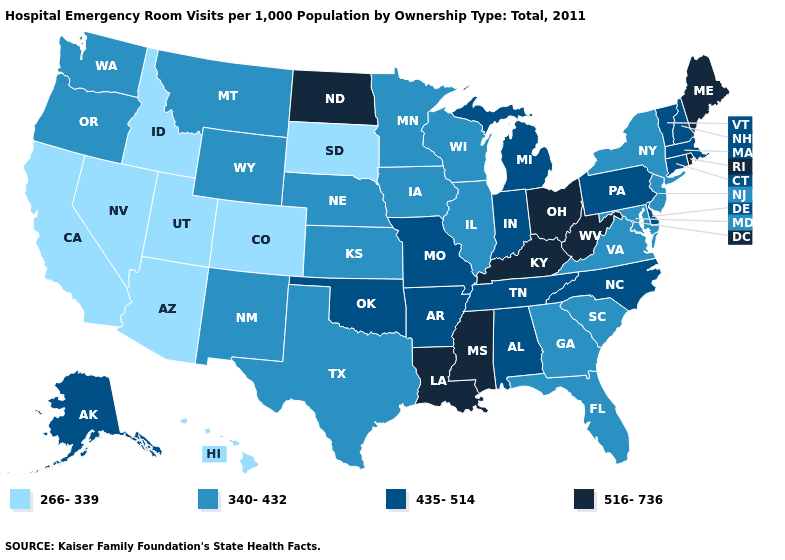What is the value of Utah?
Short answer required. 266-339. Name the states that have a value in the range 435-514?
Answer briefly. Alabama, Alaska, Arkansas, Connecticut, Delaware, Indiana, Massachusetts, Michigan, Missouri, New Hampshire, North Carolina, Oklahoma, Pennsylvania, Tennessee, Vermont. Which states have the highest value in the USA?
Write a very short answer. Kentucky, Louisiana, Maine, Mississippi, North Dakota, Ohio, Rhode Island, West Virginia. Among the states that border Nevada , does California have the highest value?
Be succinct. No. What is the lowest value in states that border Alabama?
Give a very brief answer. 340-432. Name the states that have a value in the range 266-339?
Give a very brief answer. Arizona, California, Colorado, Hawaii, Idaho, Nevada, South Dakota, Utah. Which states have the highest value in the USA?
Concise answer only. Kentucky, Louisiana, Maine, Mississippi, North Dakota, Ohio, Rhode Island, West Virginia. What is the value of Nebraska?
Quick response, please. 340-432. Does Texas have a higher value than Connecticut?
Quick response, please. No. Name the states that have a value in the range 435-514?
Keep it brief. Alabama, Alaska, Arkansas, Connecticut, Delaware, Indiana, Massachusetts, Michigan, Missouri, New Hampshire, North Carolina, Oklahoma, Pennsylvania, Tennessee, Vermont. What is the value of Illinois?
Be succinct. 340-432. Name the states that have a value in the range 340-432?
Short answer required. Florida, Georgia, Illinois, Iowa, Kansas, Maryland, Minnesota, Montana, Nebraska, New Jersey, New Mexico, New York, Oregon, South Carolina, Texas, Virginia, Washington, Wisconsin, Wyoming. Name the states that have a value in the range 266-339?
Give a very brief answer. Arizona, California, Colorado, Hawaii, Idaho, Nevada, South Dakota, Utah. Name the states that have a value in the range 340-432?
Keep it brief. Florida, Georgia, Illinois, Iowa, Kansas, Maryland, Minnesota, Montana, Nebraska, New Jersey, New Mexico, New York, Oregon, South Carolina, Texas, Virginia, Washington, Wisconsin, Wyoming. Does Alaska have the highest value in the West?
Be succinct. Yes. 